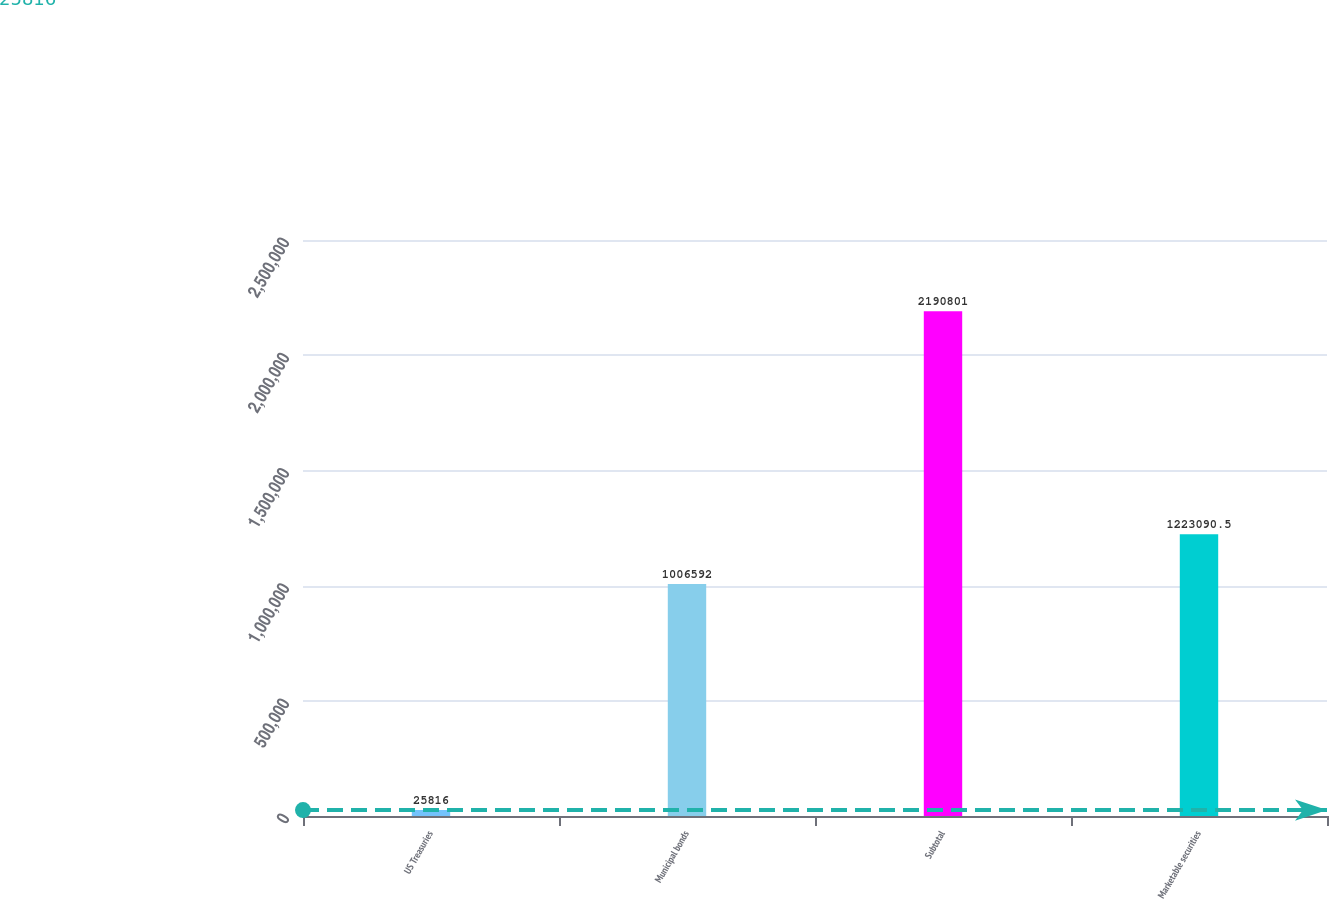Convert chart to OTSL. <chart><loc_0><loc_0><loc_500><loc_500><bar_chart><fcel>US Treasuries<fcel>Municipal bonds<fcel>Subtotal<fcel>Marketable securities<nl><fcel>25816<fcel>1.00659e+06<fcel>2.1908e+06<fcel>1.22309e+06<nl></chart> 